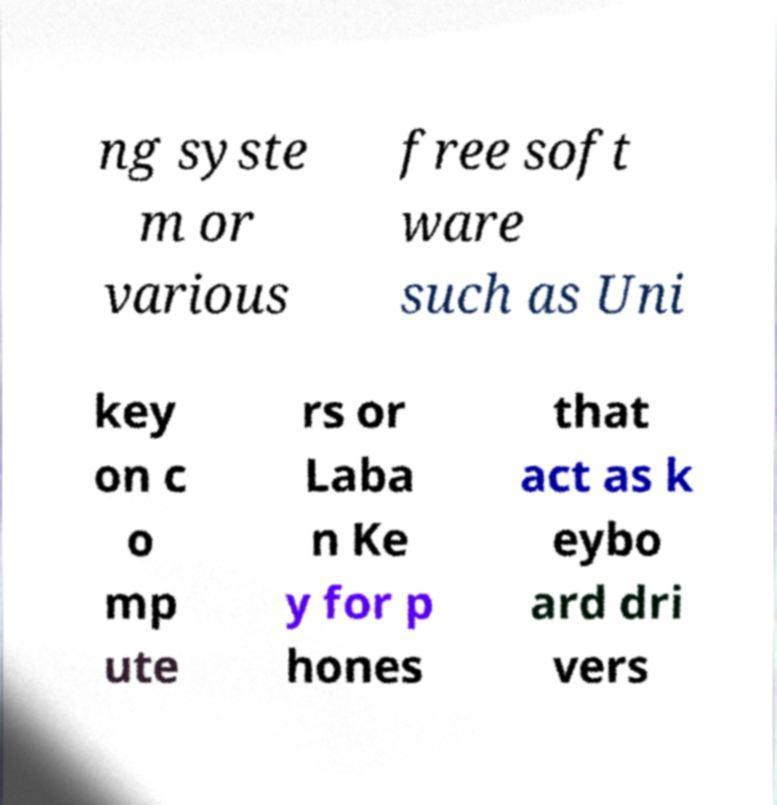Could you assist in decoding the text presented in this image and type it out clearly? ng syste m or various free soft ware such as Uni key on c o mp ute rs or Laba n Ke y for p hones that act as k eybo ard dri vers 